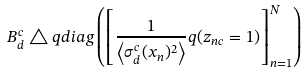Convert formula to latex. <formula><loc_0><loc_0><loc_500><loc_500>B _ { d } ^ { c } \triangle q d i a g \left ( \left [ \frac { 1 } { \left < \sigma _ { d } ^ { c } ( x _ { n } ) ^ { 2 } \right > } q ( z _ { n c } = 1 ) \right ] _ { n = 1 } ^ { N } \right )</formula> 